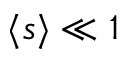Convert formula to latex. <formula><loc_0><loc_0><loc_500><loc_500>\langle s \rangle \ll 1</formula> 